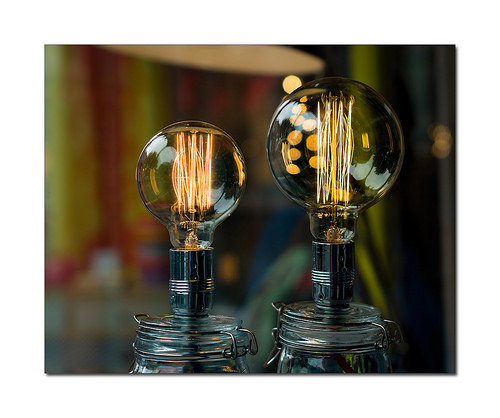<image>
Is there a reflection on the bulb? Yes. Looking at the image, I can see the reflection is positioned on top of the bulb, with the bulb providing support. 